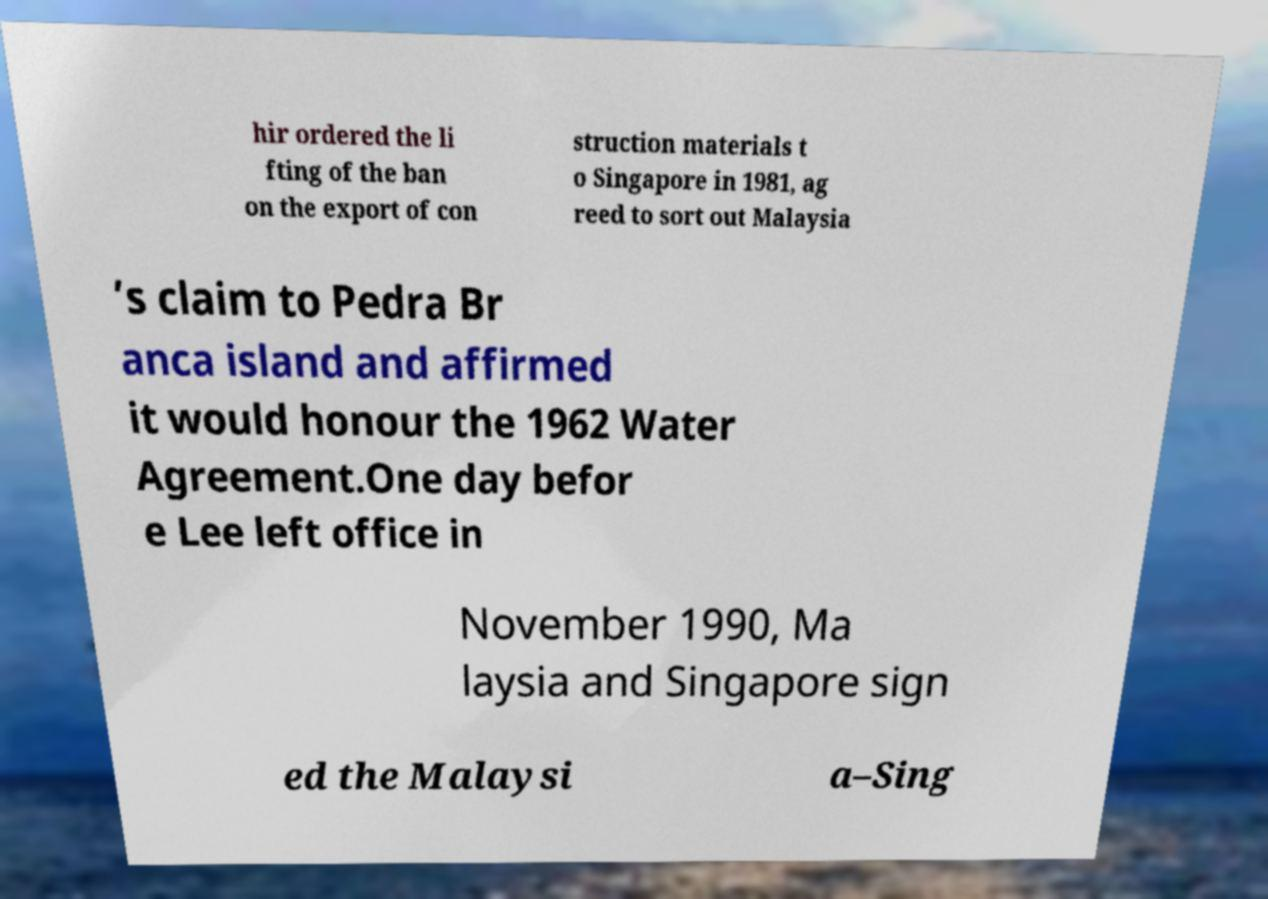Can you read and provide the text displayed in the image?This photo seems to have some interesting text. Can you extract and type it out for me? hir ordered the li fting of the ban on the export of con struction materials t o Singapore in 1981, ag reed to sort out Malaysia ’s claim to Pedra Br anca island and affirmed it would honour the 1962 Water Agreement.One day befor e Lee left office in November 1990, Ma laysia and Singapore sign ed the Malaysi a–Sing 